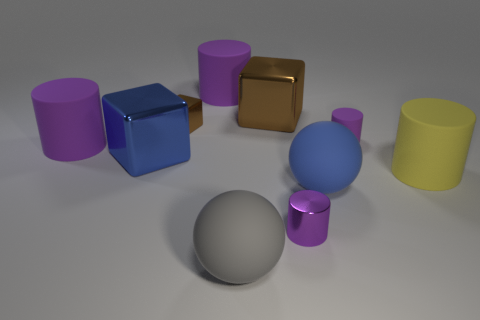Do the small cylinder that is behind the big blue matte thing and the shiny cylinder have the same color? The small cylinder located behind the large blue matte object and the shiny cylinder indeed share the same color. Both exhibit a hue that could be discerned as silver or gray, likely due to the reflective quality of their surfaces which gives the small cylinder a shiny appearance, while the larger one has a matte finish. 